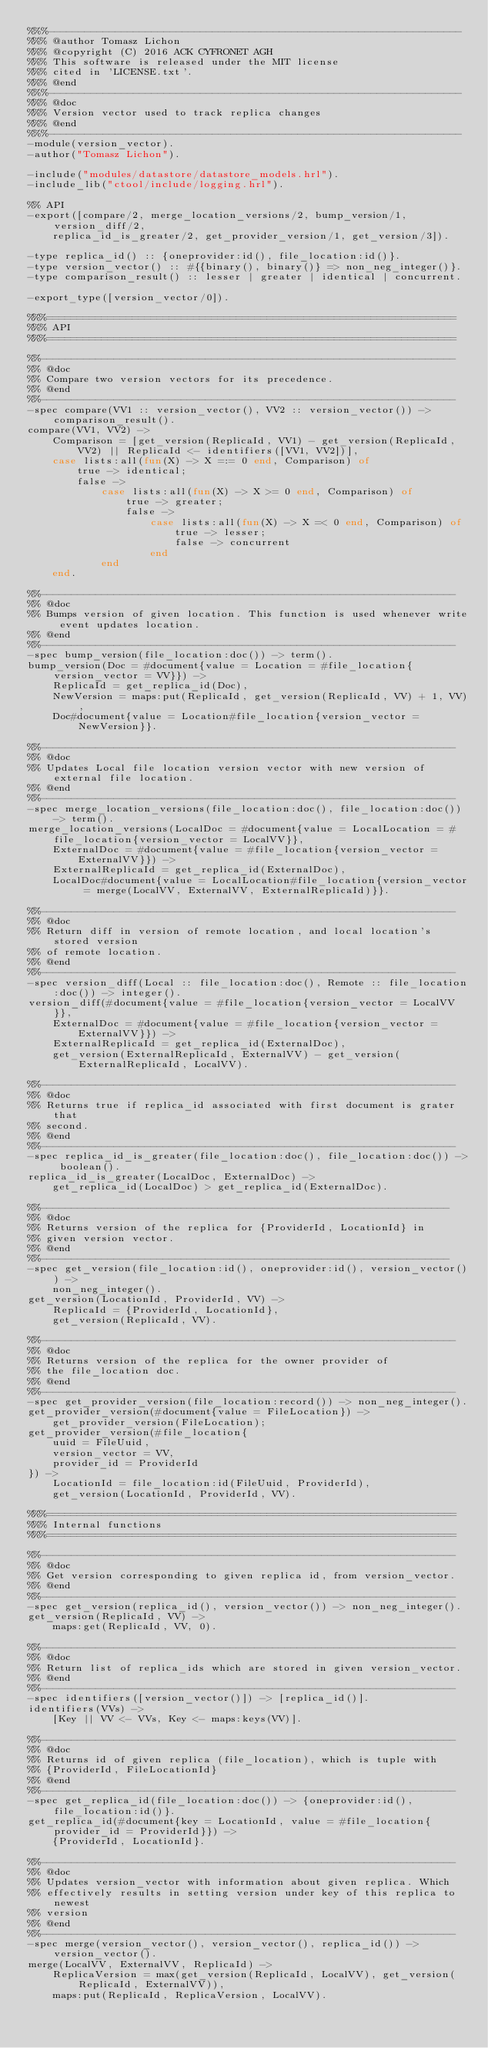<code> <loc_0><loc_0><loc_500><loc_500><_Erlang_>%%%--------------------------------------------------------------------
%%% @author Tomasz Lichon
%%% @copyright (C) 2016 ACK CYFRONET AGH
%%% This software is released under the MIT license
%%% cited in 'LICENSE.txt'.
%%% @end
%%%--------------------------------------------------------------------
%%% @doc
%%% Version vector used to track replica changes
%%% @end
%%%--------------------------------------------------------------------
-module(version_vector).
-author("Tomasz Lichon").

-include("modules/datastore/datastore_models.hrl").
-include_lib("ctool/include/logging.hrl").

%% API
-export([compare/2, merge_location_versions/2, bump_version/1, version_diff/2,
    replica_id_is_greater/2, get_provider_version/1, get_version/3]).

-type replica_id() :: {oneprovider:id(), file_location:id()}.
-type version_vector() :: #{{binary(), binary()} => non_neg_integer()}.
-type comparison_result() :: lesser | greater | identical | concurrent.

-export_type([version_vector/0]).

%%%===================================================================
%%% API
%%%===================================================================

%%--------------------------------------------------------------------
%% @doc
%% Compare two version vectors for its precedence.
%% @end
%%--------------------------------------------------------------------
-spec compare(VV1 :: version_vector(), VV2 :: version_vector()) -> comparison_result().
compare(VV1, VV2) ->
    Comparison = [get_version(ReplicaId, VV1) - get_version(ReplicaId, VV2) || ReplicaId <- identifiers([VV1, VV2])],
    case lists:all(fun(X) -> X =:= 0 end, Comparison) of
        true -> identical;
        false ->
            case lists:all(fun(X) -> X >= 0 end, Comparison) of
                true -> greater;
                false ->
                    case lists:all(fun(X) -> X =< 0 end, Comparison) of
                        true -> lesser;
                        false -> concurrent
                    end
            end
    end.

%%--------------------------------------------------------------------
%% @doc
%% Bumps version of given location. This function is used whenever write event updates location.
%% @end
%%--------------------------------------------------------------------
-spec bump_version(file_location:doc()) -> term().
bump_version(Doc = #document{value = Location = #file_location{version_vector = VV}}) ->
    ReplicaId = get_replica_id(Doc),
    NewVersion = maps:put(ReplicaId, get_version(ReplicaId, VV) + 1, VV),
    Doc#document{value = Location#file_location{version_vector = NewVersion}}.

%%--------------------------------------------------------------------
%% @doc
%% Updates Local file location version vector with new version of external file location.
%% @end
%%--------------------------------------------------------------------
-spec merge_location_versions(file_location:doc(), file_location:doc()) -> term().
merge_location_versions(LocalDoc = #document{value = LocalLocation = #file_location{version_vector = LocalVV}},
    ExternalDoc = #document{value = #file_location{version_vector = ExternalVV}}) ->
    ExternalReplicaId = get_replica_id(ExternalDoc),
    LocalDoc#document{value = LocalLocation#file_location{version_vector = merge(LocalVV, ExternalVV, ExternalReplicaId)}}.

%%--------------------------------------------------------------------
%% @doc
%% Return diff in version of remote location, and local location's stored version
%% of remote location.
%% @end
%%--------------------------------------------------------------------
-spec version_diff(Local :: file_location:doc(), Remote :: file_location:doc()) -> integer().
version_diff(#document{value = #file_location{version_vector = LocalVV}},
    ExternalDoc = #document{value = #file_location{version_vector = ExternalVV}}) ->
    ExternalReplicaId = get_replica_id(ExternalDoc),
    get_version(ExternalReplicaId, ExternalVV) - get_version(ExternalReplicaId, LocalVV).

%%--------------------------------------------------------------------
%% @doc
%% Returns true if replica_id associated with first document is grater that
%% second.
%% @end
%%--------------------------------------------------------------------
-spec replica_id_is_greater(file_location:doc(), file_location:doc()) -> boolean().
replica_id_is_greater(LocalDoc, ExternalDoc) ->
    get_replica_id(LocalDoc) > get_replica_id(ExternalDoc).

%%-------------------------------------------------------------------
%% @doc
%% Returns version of the replica for {ProviderId, LocationId} in
%% given version vector.
%% @end
%%-------------------------------------------------------------------
-spec get_version(file_location:id(), oneprovider:id(), version_vector()) ->
    non_neg_integer().
get_version(LocationId, ProviderId, VV) ->
    ReplicaId = {ProviderId, LocationId},
    get_version(ReplicaId, VV).

%%--------------------------------------------------------------------
%% @doc
%% Returns version of the replica for the owner provider of
%% the file_location doc.
%% @end
%%--------------------------------------------------------------------
-spec get_provider_version(file_location:record()) -> non_neg_integer().
get_provider_version(#document{value = FileLocation}) ->
    get_provider_version(FileLocation);
get_provider_version(#file_location{
    uuid = FileUuid,
    version_vector = VV,
    provider_id = ProviderId
}) ->
    LocationId = file_location:id(FileUuid, ProviderId),
    get_version(LocationId, ProviderId, VV).

%%%===================================================================
%%% Internal functions
%%%===================================================================

%%--------------------------------------------------------------------
%% @doc
%% Get version corresponding to given replica id, from version_vector.
%% @end
%%--------------------------------------------------------------------
-spec get_version(replica_id(), version_vector()) -> non_neg_integer().
get_version(ReplicaId, VV) ->
    maps:get(ReplicaId, VV, 0).

%%--------------------------------------------------------------------
%% @doc
%% Return list of replica_ids which are stored in given version_vector.
%% @end
%%--------------------------------------------------------------------
-spec identifiers([version_vector()]) -> [replica_id()].
identifiers(VVs) ->
    [Key || VV <- VVs, Key <- maps:keys(VV)].

%%--------------------------------------------------------------------
%% @doc
%% Returns id of given replica (file_location), which is tuple with
%% {ProviderId, FileLocationId}
%% @end
%%--------------------------------------------------------------------
-spec get_replica_id(file_location:doc()) -> {oneprovider:id(), file_location:id()}.
get_replica_id(#document{key = LocationId, value = #file_location{provider_id = ProviderId}}) ->
    {ProviderId, LocationId}.

%%--------------------------------------------------------------------
%% @doc
%% Updates version_vector with information about given replica. Which
%% effectively results in setting version under key of this replica to newest
%% version
%% @end
%%--------------------------------------------------------------------
-spec merge(version_vector(), version_vector(), replica_id()) -> version_vector().
merge(LocalVV, ExternalVV, ReplicaId) ->
    ReplicaVersion = max(get_version(ReplicaId, LocalVV), get_version(ReplicaId, ExternalVV)),
    maps:put(ReplicaId, ReplicaVersion, LocalVV).
</code> 